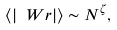Convert formula to latex. <formula><loc_0><loc_0><loc_500><loc_500>\langle | \ W r | \rangle \sim N ^ { \zeta } ,</formula> 